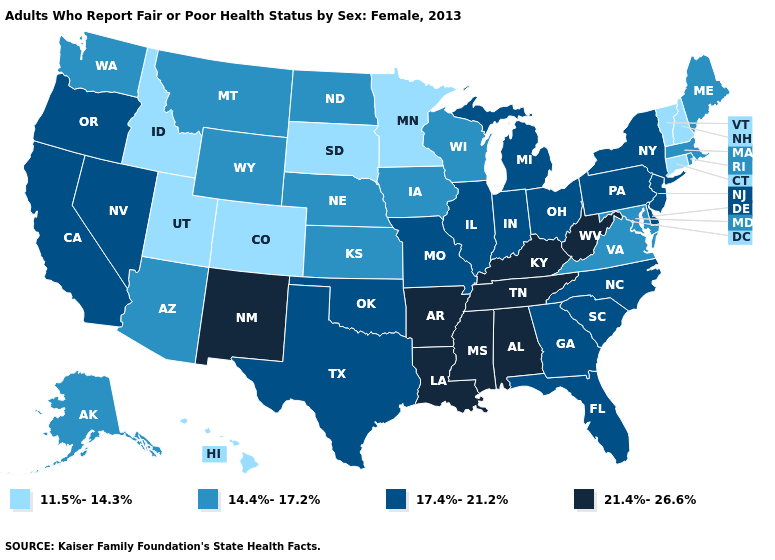Is the legend a continuous bar?
Concise answer only. No. What is the value of Illinois?
Keep it brief. 17.4%-21.2%. Does New York have the same value as Alabama?
Answer briefly. No. Does the first symbol in the legend represent the smallest category?
Answer briefly. Yes. What is the highest value in states that border Indiana?
Answer briefly. 21.4%-26.6%. What is the highest value in the South ?
Concise answer only. 21.4%-26.6%. Among the states that border Utah , does Wyoming have the highest value?
Write a very short answer. No. How many symbols are there in the legend?
Write a very short answer. 4. What is the highest value in the USA?
Be succinct. 21.4%-26.6%. Which states have the lowest value in the USA?
Short answer required. Colorado, Connecticut, Hawaii, Idaho, Minnesota, New Hampshire, South Dakota, Utah, Vermont. Does the first symbol in the legend represent the smallest category?
Keep it brief. Yes. Does Alabama have the lowest value in the South?
Keep it brief. No. Does Idaho have the highest value in the USA?
Be succinct. No. What is the lowest value in the West?
Answer briefly. 11.5%-14.3%. Does Utah have the lowest value in the USA?
Give a very brief answer. Yes. 